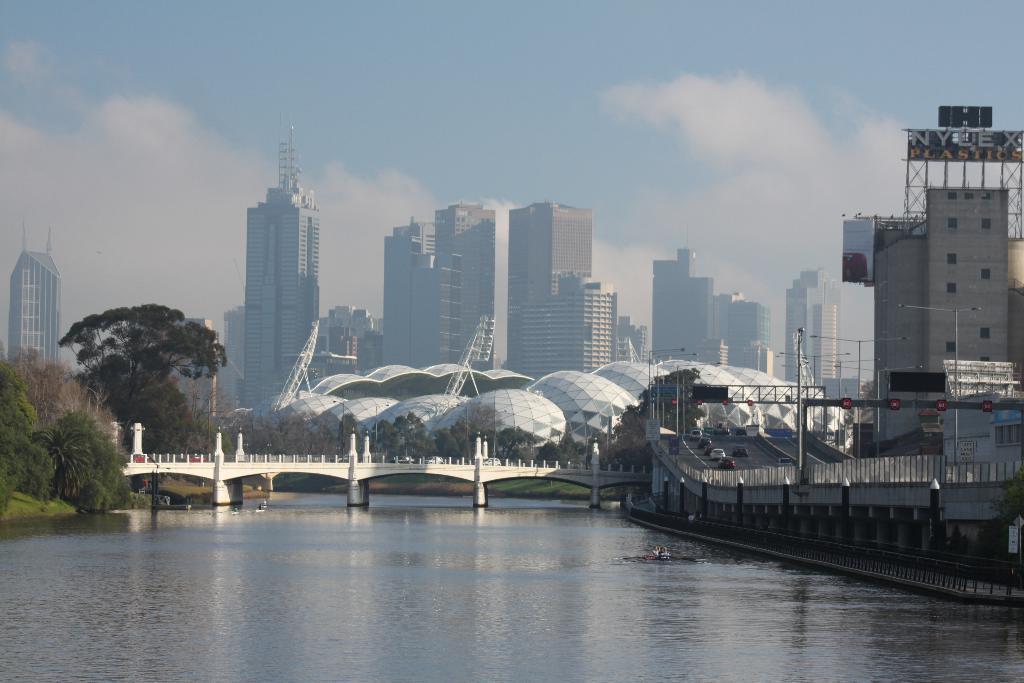Describe this image in one or two sentences. In this image we can see some buildings, trees, dome architectures, poles, road, vehicles, name board, bridge and some other objects. At the top of the image there is the sky. At the bottom of the image there is water. 